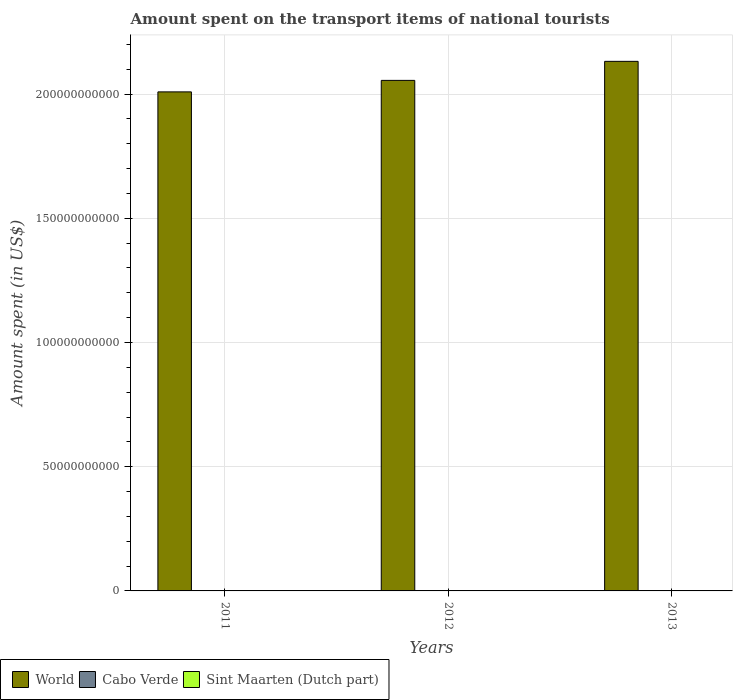How many groups of bars are there?
Your response must be concise. 3. Are the number of bars on each tick of the X-axis equal?
Your answer should be very brief. Yes. How many bars are there on the 2nd tick from the left?
Your response must be concise. 3. How many bars are there on the 3rd tick from the right?
Your answer should be very brief. 3. What is the amount spent on the transport items of national tourists in World in 2012?
Offer a very short reply. 2.06e+11. Across all years, what is the maximum amount spent on the transport items of national tourists in Sint Maarten (Dutch part)?
Offer a very short reply. 1.40e+07. Across all years, what is the minimum amount spent on the transport items of national tourists in Cabo Verde?
Give a very brief answer. 4.90e+07. In which year was the amount spent on the transport items of national tourists in Sint Maarten (Dutch part) maximum?
Your answer should be very brief. 2013. In which year was the amount spent on the transport items of national tourists in Sint Maarten (Dutch part) minimum?
Provide a succinct answer. 2011. What is the total amount spent on the transport items of national tourists in Sint Maarten (Dutch part) in the graph?
Keep it short and to the point. 3.60e+07. What is the difference between the amount spent on the transport items of national tourists in World in 2012 and that in 2013?
Provide a succinct answer. -7.66e+09. What is the difference between the amount spent on the transport items of national tourists in Sint Maarten (Dutch part) in 2011 and the amount spent on the transport items of national tourists in World in 2012?
Offer a terse response. -2.06e+11. What is the average amount spent on the transport items of national tourists in Cabo Verde per year?
Offer a terse response. 5.87e+07. In the year 2012, what is the difference between the amount spent on the transport items of national tourists in Cabo Verde and amount spent on the transport items of national tourists in Sint Maarten (Dutch part)?
Ensure brevity in your answer.  4.50e+07. In how many years, is the amount spent on the transport items of national tourists in Sint Maarten (Dutch part) greater than 210000000000 US$?
Provide a short and direct response. 0. What is the ratio of the amount spent on the transport items of national tourists in World in 2011 to that in 2013?
Offer a very short reply. 0.94. Is the amount spent on the transport items of national tourists in Sint Maarten (Dutch part) in 2011 less than that in 2013?
Offer a very short reply. Yes. What is the difference between the highest and the lowest amount spent on the transport items of national tourists in Cabo Verde?
Offer a terse response. 2.10e+07. In how many years, is the amount spent on the transport items of national tourists in Sint Maarten (Dutch part) greater than the average amount spent on the transport items of national tourists in Sint Maarten (Dutch part) taken over all years?
Provide a short and direct response. 1. What does the 1st bar from the right in 2013 represents?
Provide a short and direct response. Sint Maarten (Dutch part). How many bars are there?
Provide a succinct answer. 9. Are all the bars in the graph horizontal?
Make the answer very short. No. How many years are there in the graph?
Give a very brief answer. 3. What is the difference between two consecutive major ticks on the Y-axis?
Make the answer very short. 5.00e+1. Are the values on the major ticks of Y-axis written in scientific E-notation?
Give a very brief answer. No. Does the graph contain any zero values?
Provide a short and direct response. No. Does the graph contain grids?
Give a very brief answer. Yes. Where does the legend appear in the graph?
Offer a very short reply. Bottom left. What is the title of the graph?
Your response must be concise. Amount spent on the transport items of national tourists. What is the label or title of the X-axis?
Offer a very short reply. Years. What is the label or title of the Y-axis?
Provide a short and direct response. Amount spent (in US$). What is the Amount spent (in US$) in World in 2011?
Offer a very short reply. 2.01e+11. What is the Amount spent (in US$) of Cabo Verde in 2011?
Provide a short and direct response. 7.00e+07. What is the Amount spent (in US$) of Sint Maarten (Dutch part) in 2011?
Provide a succinct answer. 1.00e+07. What is the Amount spent (in US$) of World in 2012?
Your answer should be compact. 2.06e+11. What is the Amount spent (in US$) in Cabo Verde in 2012?
Your answer should be very brief. 5.70e+07. What is the Amount spent (in US$) in World in 2013?
Keep it short and to the point. 2.13e+11. What is the Amount spent (in US$) in Cabo Verde in 2013?
Your answer should be compact. 4.90e+07. What is the Amount spent (in US$) in Sint Maarten (Dutch part) in 2013?
Your response must be concise. 1.40e+07. Across all years, what is the maximum Amount spent (in US$) in World?
Make the answer very short. 2.13e+11. Across all years, what is the maximum Amount spent (in US$) in Cabo Verde?
Provide a succinct answer. 7.00e+07. Across all years, what is the maximum Amount spent (in US$) of Sint Maarten (Dutch part)?
Ensure brevity in your answer.  1.40e+07. Across all years, what is the minimum Amount spent (in US$) in World?
Make the answer very short. 2.01e+11. Across all years, what is the minimum Amount spent (in US$) in Cabo Verde?
Your answer should be compact. 4.90e+07. What is the total Amount spent (in US$) of World in the graph?
Keep it short and to the point. 6.20e+11. What is the total Amount spent (in US$) of Cabo Verde in the graph?
Your answer should be very brief. 1.76e+08. What is the total Amount spent (in US$) in Sint Maarten (Dutch part) in the graph?
Make the answer very short. 3.60e+07. What is the difference between the Amount spent (in US$) in World in 2011 and that in 2012?
Your answer should be very brief. -4.63e+09. What is the difference between the Amount spent (in US$) of Cabo Verde in 2011 and that in 2012?
Keep it short and to the point. 1.30e+07. What is the difference between the Amount spent (in US$) in World in 2011 and that in 2013?
Offer a very short reply. -1.23e+1. What is the difference between the Amount spent (in US$) in Cabo Verde in 2011 and that in 2013?
Your answer should be very brief. 2.10e+07. What is the difference between the Amount spent (in US$) in World in 2012 and that in 2013?
Your answer should be very brief. -7.66e+09. What is the difference between the Amount spent (in US$) in Cabo Verde in 2012 and that in 2013?
Your answer should be compact. 8.00e+06. What is the difference between the Amount spent (in US$) in World in 2011 and the Amount spent (in US$) in Cabo Verde in 2012?
Ensure brevity in your answer.  2.01e+11. What is the difference between the Amount spent (in US$) in World in 2011 and the Amount spent (in US$) in Sint Maarten (Dutch part) in 2012?
Make the answer very short. 2.01e+11. What is the difference between the Amount spent (in US$) in Cabo Verde in 2011 and the Amount spent (in US$) in Sint Maarten (Dutch part) in 2012?
Provide a short and direct response. 5.80e+07. What is the difference between the Amount spent (in US$) in World in 2011 and the Amount spent (in US$) in Cabo Verde in 2013?
Offer a very short reply. 2.01e+11. What is the difference between the Amount spent (in US$) in World in 2011 and the Amount spent (in US$) in Sint Maarten (Dutch part) in 2013?
Your answer should be very brief. 2.01e+11. What is the difference between the Amount spent (in US$) in Cabo Verde in 2011 and the Amount spent (in US$) in Sint Maarten (Dutch part) in 2013?
Your answer should be compact. 5.60e+07. What is the difference between the Amount spent (in US$) of World in 2012 and the Amount spent (in US$) of Cabo Verde in 2013?
Ensure brevity in your answer.  2.05e+11. What is the difference between the Amount spent (in US$) of World in 2012 and the Amount spent (in US$) of Sint Maarten (Dutch part) in 2013?
Your answer should be compact. 2.06e+11. What is the difference between the Amount spent (in US$) of Cabo Verde in 2012 and the Amount spent (in US$) of Sint Maarten (Dutch part) in 2013?
Provide a short and direct response. 4.30e+07. What is the average Amount spent (in US$) in World per year?
Your answer should be compact. 2.07e+11. What is the average Amount spent (in US$) in Cabo Verde per year?
Your answer should be very brief. 5.87e+07. In the year 2011, what is the difference between the Amount spent (in US$) in World and Amount spent (in US$) in Cabo Verde?
Ensure brevity in your answer.  2.01e+11. In the year 2011, what is the difference between the Amount spent (in US$) in World and Amount spent (in US$) in Sint Maarten (Dutch part)?
Provide a succinct answer. 2.01e+11. In the year 2011, what is the difference between the Amount spent (in US$) in Cabo Verde and Amount spent (in US$) in Sint Maarten (Dutch part)?
Give a very brief answer. 6.00e+07. In the year 2012, what is the difference between the Amount spent (in US$) of World and Amount spent (in US$) of Cabo Verde?
Make the answer very short. 2.05e+11. In the year 2012, what is the difference between the Amount spent (in US$) of World and Amount spent (in US$) of Sint Maarten (Dutch part)?
Offer a very short reply. 2.06e+11. In the year 2012, what is the difference between the Amount spent (in US$) in Cabo Verde and Amount spent (in US$) in Sint Maarten (Dutch part)?
Provide a short and direct response. 4.50e+07. In the year 2013, what is the difference between the Amount spent (in US$) in World and Amount spent (in US$) in Cabo Verde?
Your response must be concise. 2.13e+11. In the year 2013, what is the difference between the Amount spent (in US$) of World and Amount spent (in US$) of Sint Maarten (Dutch part)?
Your response must be concise. 2.13e+11. In the year 2013, what is the difference between the Amount spent (in US$) in Cabo Verde and Amount spent (in US$) in Sint Maarten (Dutch part)?
Your answer should be very brief. 3.50e+07. What is the ratio of the Amount spent (in US$) in World in 2011 to that in 2012?
Offer a terse response. 0.98. What is the ratio of the Amount spent (in US$) of Cabo Verde in 2011 to that in 2012?
Your answer should be very brief. 1.23. What is the ratio of the Amount spent (in US$) in World in 2011 to that in 2013?
Your answer should be compact. 0.94. What is the ratio of the Amount spent (in US$) of Cabo Verde in 2011 to that in 2013?
Your answer should be very brief. 1.43. What is the ratio of the Amount spent (in US$) in World in 2012 to that in 2013?
Ensure brevity in your answer.  0.96. What is the ratio of the Amount spent (in US$) in Cabo Verde in 2012 to that in 2013?
Your response must be concise. 1.16. What is the ratio of the Amount spent (in US$) in Sint Maarten (Dutch part) in 2012 to that in 2013?
Provide a succinct answer. 0.86. What is the difference between the highest and the second highest Amount spent (in US$) in World?
Provide a succinct answer. 7.66e+09. What is the difference between the highest and the second highest Amount spent (in US$) in Cabo Verde?
Your answer should be very brief. 1.30e+07. What is the difference between the highest and the lowest Amount spent (in US$) in World?
Provide a short and direct response. 1.23e+1. What is the difference between the highest and the lowest Amount spent (in US$) of Cabo Verde?
Your response must be concise. 2.10e+07. What is the difference between the highest and the lowest Amount spent (in US$) in Sint Maarten (Dutch part)?
Your answer should be very brief. 4.00e+06. 